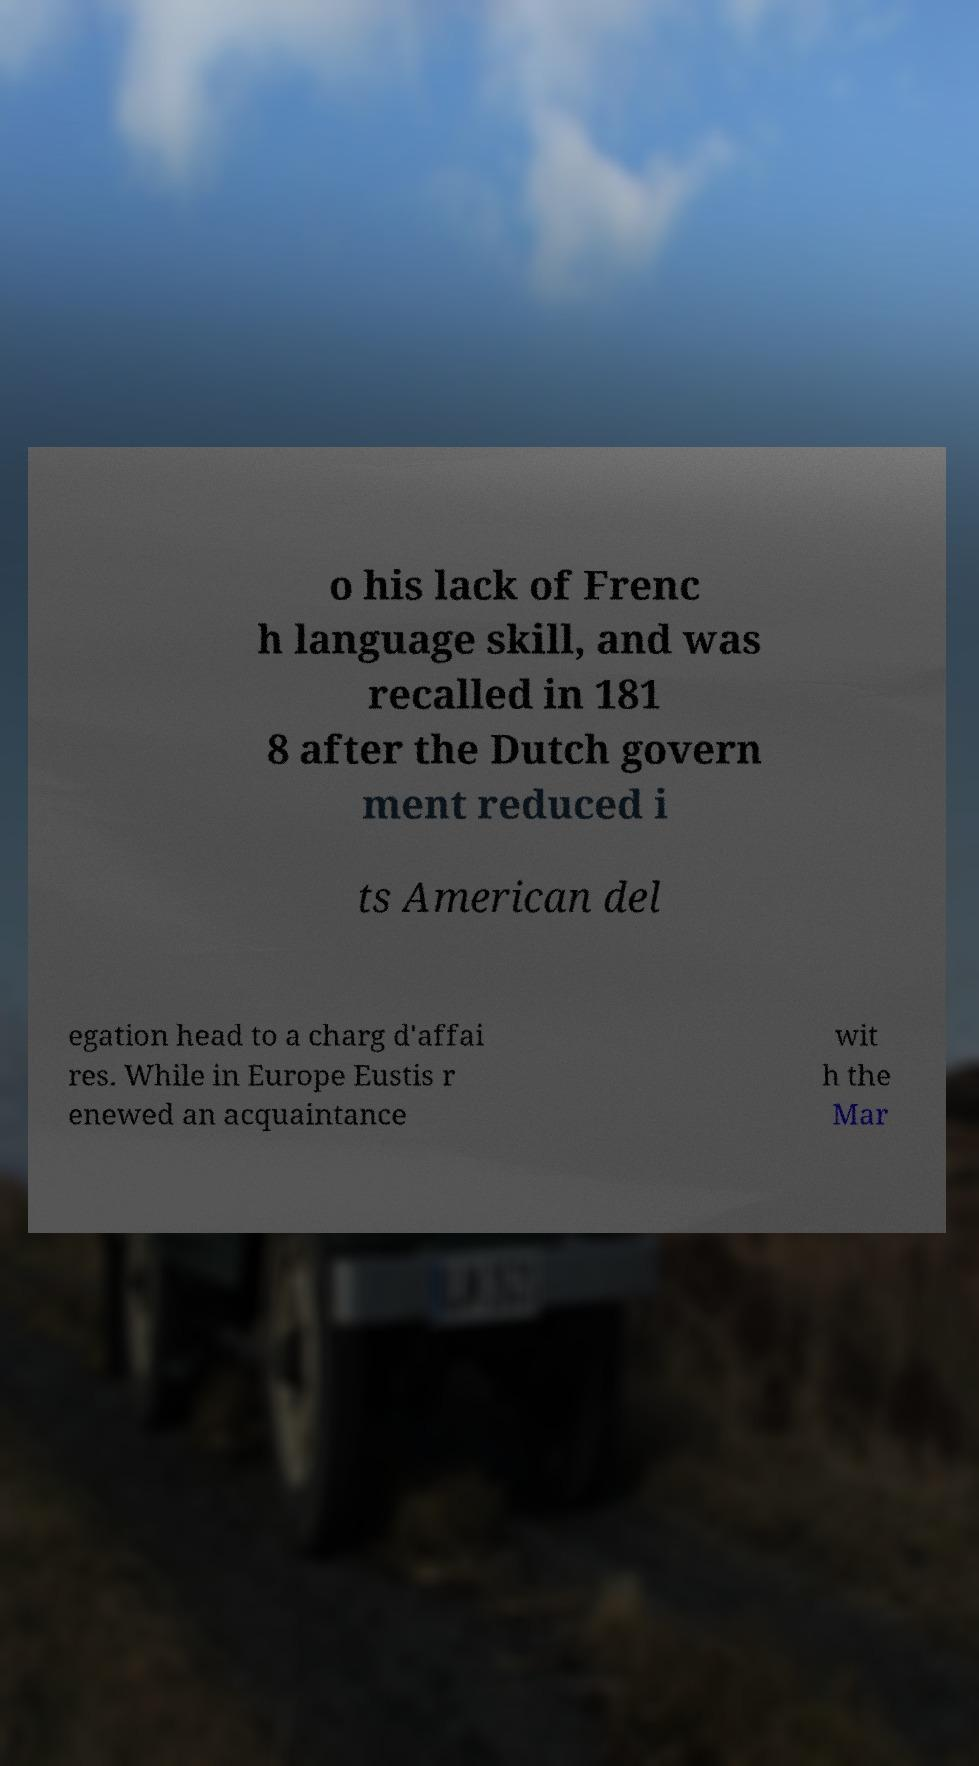There's text embedded in this image that I need extracted. Can you transcribe it verbatim? o his lack of Frenc h language skill, and was recalled in 181 8 after the Dutch govern ment reduced i ts American del egation head to a charg d'affai res. While in Europe Eustis r enewed an acquaintance wit h the Mar 